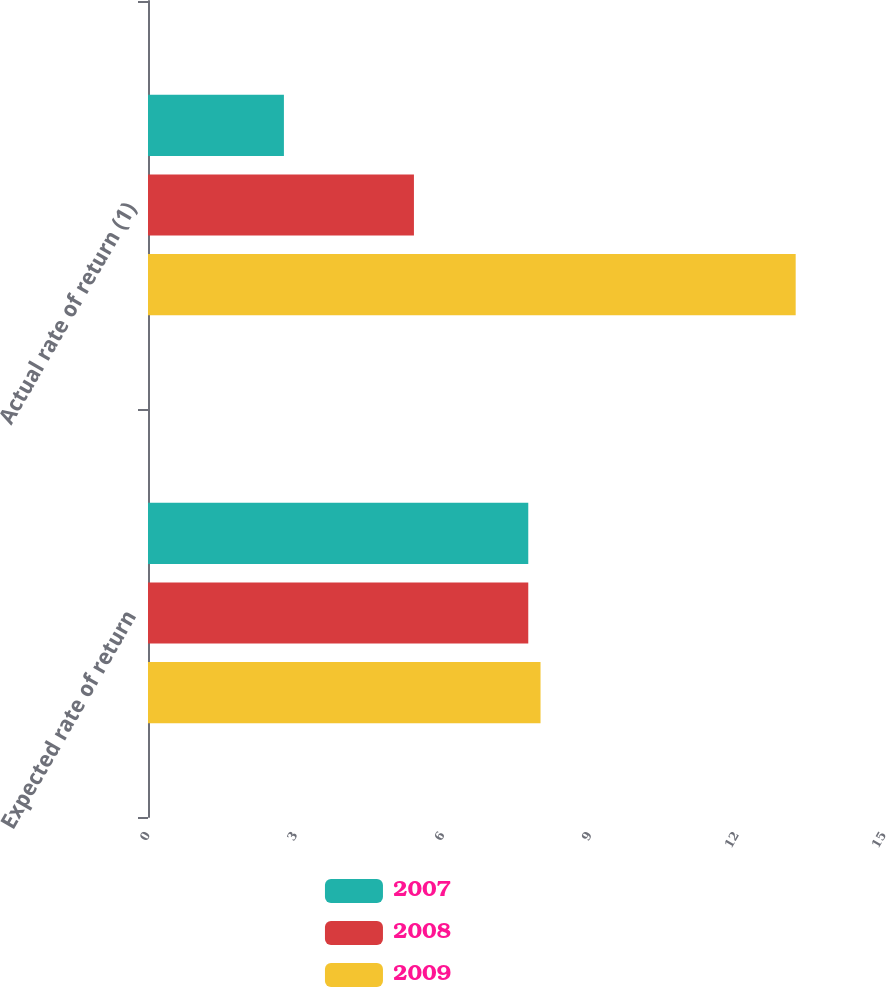Convert chart to OTSL. <chart><loc_0><loc_0><loc_500><loc_500><stacked_bar_chart><ecel><fcel>Expected rate of return<fcel>Actual rate of return (1)<nl><fcel>2007<fcel>7.75<fcel>2.77<nl><fcel>2008<fcel>7.75<fcel>5.42<nl><fcel>2009<fcel>8<fcel>13.2<nl></chart> 